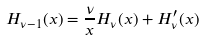Convert formula to latex. <formula><loc_0><loc_0><loc_500><loc_500>H _ { \nu - 1 } ( x ) = \frac { \nu } { x } H _ { \nu } ( x ) + H _ { \nu } ^ { \prime } ( x )</formula> 